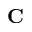<formula> <loc_0><loc_0><loc_500><loc_500>C</formula> 